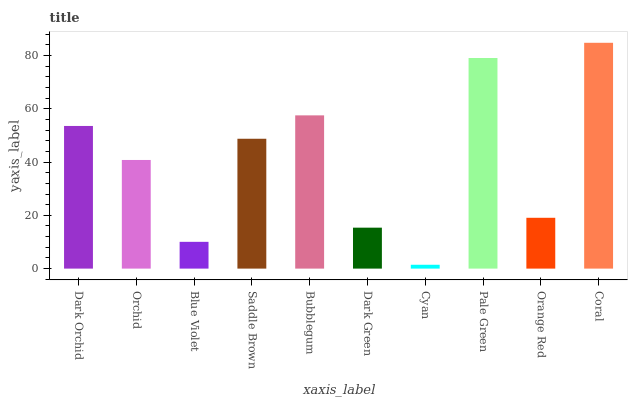Is Cyan the minimum?
Answer yes or no. Yes. Is Coral the maximum?
Answer yes or no. Yes. Is Orchid the minimum?
Answer yes or no. No. Is Orchid the maximum?
Answer yes or no. No. Is Dark Orchid greater than Orchid?
Answer yes or no. Yes. Is Orchid less than Dark Orchid?
Answer yes or no. Yes. Is Orchid greater than Dark Orchid?
Answer yes or no. No. Is Dark Orchid less than Orchid?
Answer yes or no. No. Is Saddle Brown the high median?
Answer yes or no. Yes. Is Orchid the low median?
Answer yes or no. Yes. Is Cyan the high median?
Answer yes or no. No. Is Coral the low median?
Answer yes or no. No. 